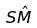<formula> <loc_0><loc_0><loc_500><loc_500>S \hat { M }</formula> 